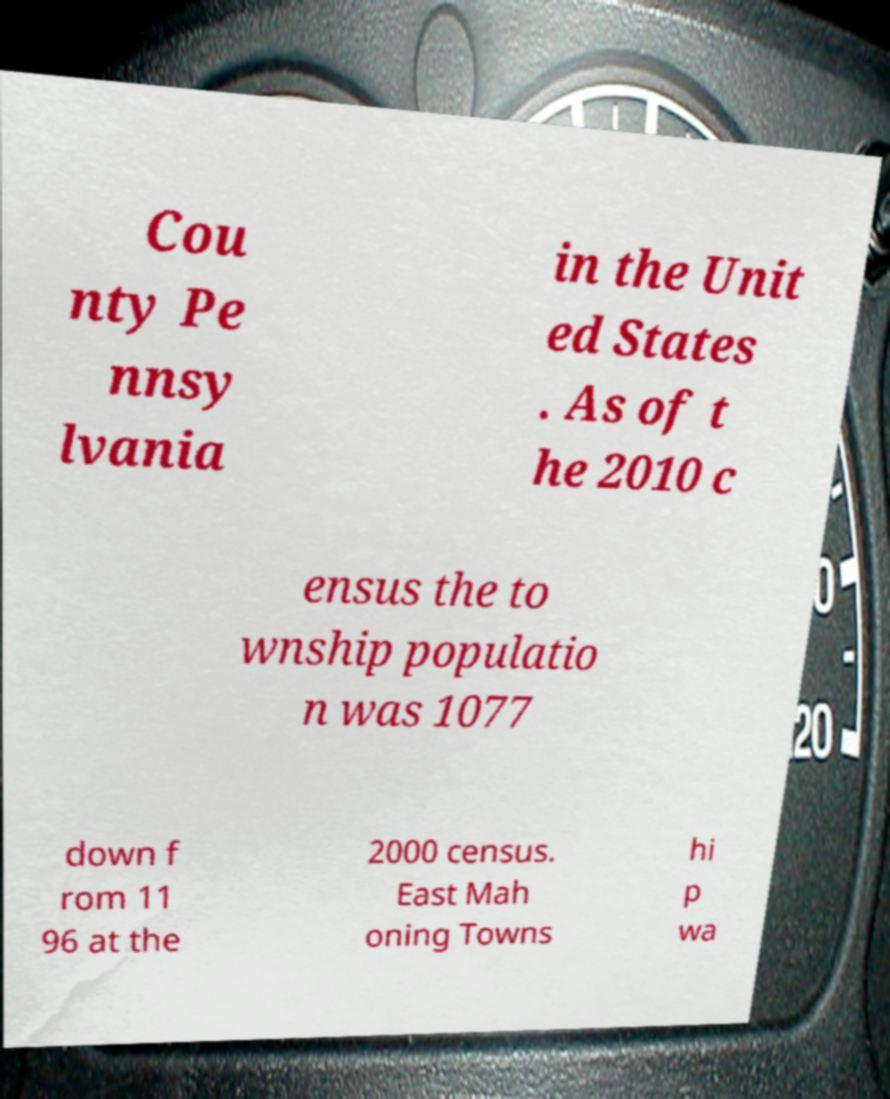I need the written content from this picture converted into text. Can you do that? Cou nty Pe nnsy lvania in the Unit ed States . As of t he 2010 c ensus the to wnship populatio n was 1077 down f rom 11 96 at the 2000 census. East Mah oning Towns hi p wa 